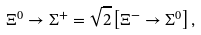<formula> <loc_0><loc_0><loc_500><loc_500>\Xi ^ { 0 } \to \Sigma ^ { + } = \sqrt { 2 } \left [ \Xi ^ { - } \to \Sigma ^ { 0 } \right ] ,</formula> 